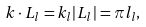<formula> <loc_0><loc_0><loc_500><loc_500>k \cdot L _ { l } = k _ { l } | L _ { l } | = \pi l _ { l } ,</formula> 